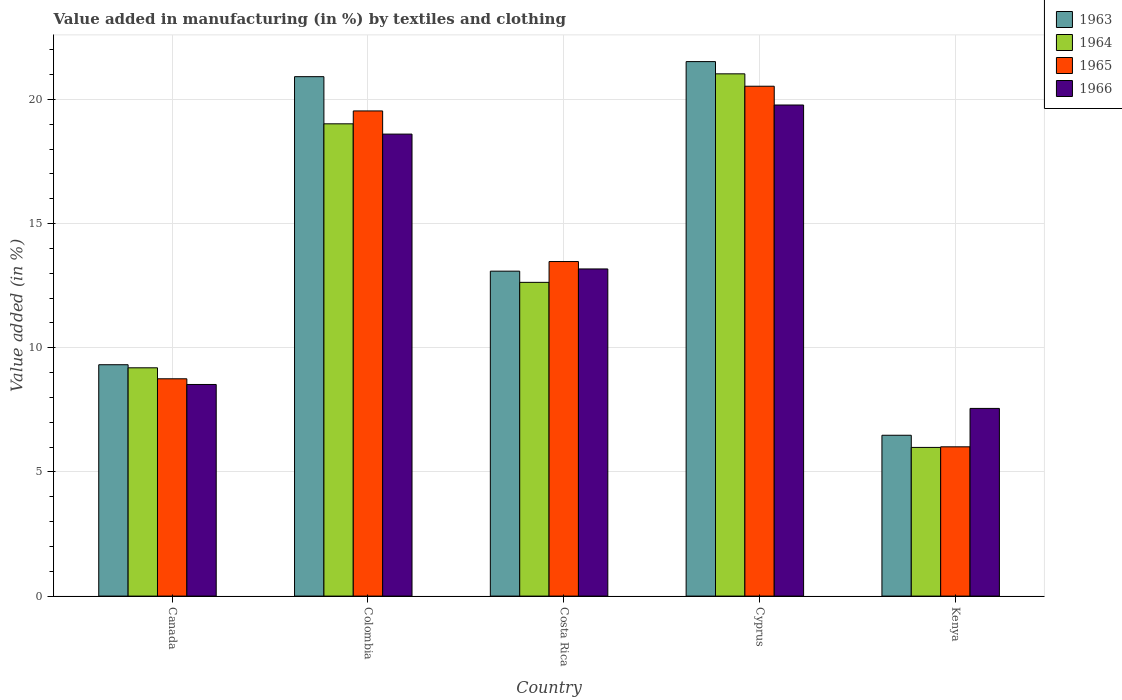How many different coloured bars are there?
Your answer should be very brief. 4. How many groups of bars are there?
Give a very brief answer. 5. How many bars are there on the 5th tick from the left?
Offer a very short reply. 4. What is the label of the 5th group of bars from the left?
Offer a terse response. Kenya. What is the percentage of value added in manufacturing by textiles and clothing in 1964 in Kenya?
Provide a succinct answer. 5.99. Across all countries, what is the maximum percentage of value added in manufacturing by textiles and clothing in 1964?
Your response must be concise. 21.03. Across all countries, what is the minimum percentage of value added in manufacturing by textiles and clothing in 1964?
Provide a succinct answer. 5.99. In which country was the percentage of value added in manufacturing by textiles and clothing in 1966 maximum?
Offer a very short reply. Cyprus. In which country was the percentage of value added in manufacturing by textiles and clothing in 1964 minimum?
Your answer should be compact. Kenya. What is the total percentage of value added in manufacturing by textiles and clothing in 1963 in the graph?
Make the answer very short. 71.32. What is the difference between the percentage of value added in manufacturing by textiles and clothing in 1963 in Canada and that in Colombia?
Provide a short and direct response. -11.6. What is the difference between the percentage of value added in manufacturing by textiles and clothing in 1966 in Kenya and the percentage of value added in manufacturing by textiles and clothing in 1965 in Colombia?
Offer a very short reply. -11.98. What is the average percentage of value added in manufacturing by textiles and clothing in 1965 per country?
Ensure brevity in your answer.  13.66. What is the difference between the percentage of value added in manufacturing by textiles and clothing of/in 1964 and percentage of value added in manufacturing by textiles and clothing of/in 1963 in Costa Rica?
Make the answer very short. -0.45. In how many countries, is the percentage of value added in manufacturing by textiles and clothing in 1964 greater than 9 %?
Give a very brief answer. 4. What is the ratio of the percentage of value added in manufacturing by textiles and clothing in 1966 in Canada to that in Cyprus?
Your answer should be very brief. 0.43. Is the difference between the percentage of value added in manufacturing by textiles and clothing in 1964 in Colombia and Kenya greater than the difference between the percentage of value added in manufacturing by textiles and clothing in 1963 in Colombia and Kenya?
Keep it short and to the point. No. What is the difference between the highest and the second highest percentage of value added in manufacturing by textiles and clothing in 1965?
Your response must be concise. -0.99. What is the difference between the highest and the lowest percentage of value added in manufacturing by textiles and clothing in 1966?
Make the answer very short. 12.22. In how many countries, is the percentage of value added in manufacturing by textiles and clothing in 1964 greater than the average percentage of value added in manufacturing by textiles and clothing in 1964 taken over all countries?
Ensure brevity in your answer.  2. Is it the case that in every country, the sum of the percentage of value added in manufacturing by textiles and clothing in 1963 and percentage of value added in manufacturing by textiles and clothing in 1966 is greater than the sum of percentage of value added in manufacturing by textiles and clothing in 1965 and percentage of value added in manufacturing by textiles and clothing in 1964?
Ensure brevity in your answer.  No. What does the 3rd bar from the left in Canada represents?
Offer a terse response. 1965. What does the 1st bar from the right in Colombia represents?
Make the answer very short. 1966. Is it the case that in every country, the sum of the percentage of value added in manufacturing by textiles and clothing in 1965 and percentage of value added in manufacturing by textiles and clothing in 1966 is greater than the percentage of value added in manufacturing by textiles and clothing in 1963?
Provide a short and direct response. Yes. How many countries are there in the graph?
Offer a very short reply. 5. What is the difference between two consecutive major ticks on the Y-axis?
Your response must be concise. 5. Are the values on the major ticks of Y-axis written in scientific E-notation?
Provide a short and direct response. No. How are the legend labels stacked?
Make the answer very short. Vertical. What is the title of the graph?
Give a very brief answer. Value added in manufacturing (in %) by textiles and clothing. What is the label or title of the Y-axis?
Give a very brief answer. Value added (in %). What is the Value added (in %) of 1963 in Canada?
Provide a succinct answer. 9.32. What is the Value added (in %) of 1964 in Canada?
Your answer should be very brief. 9.19. What is the Value added (in %) of 1965 in Canada?
Give a very brief answer. 8.75. What is the Value added (in %) of 1966 in Canada?
Ensure brevity in your answer.  8.52. What is the Value added (in %) of 1963 in Colombia?
Your response must be concise. 20.92. What is the Value added (in %) of 1964 in Colombia?
Offer a terse response. 19.02. What is the Value added (in %) of 1965 in Colombia?
Your answer should be very brief. 19.54. What is the Value added (in %) in 1966 in Colombia?
Provide a short and direct response. 18.6. What is the Value added (in %) in 1963 in Costa Rica?
Ensure brevity in your answer.  13.08. What is the Value added (in %) of 1964 in Costa Rica?
Your answer should be very brief. 12.63. What is the Value added (in %) in 1965 in Costa Rica?
Make the answer very short. 13.47. What is the Value added (in %) of 1966 in Costa Rica?
Keep it short and to the point. 13.17. What is the Value added (in %) of 1963 in Cyprus?
Offer a very short reply. 21.52. What is the Value added (in %) of 1964 in Cyprus?
Keep it short and to the point. 21.03. What is the Value added (in %) in 1965 in Cyprus?
Your answer should be very brief. 20.53. What is the Value added (in %) in 1966 in Cyprus?
Make the answer very short. 19.78. What is the Value added (in %) in 1963 in Kenya?
Keep it short and to the point. 6.48. What is the Value added (in %) of 1964 in Kenya?
Your answer should be compact. 5.99. What is the Value added (in %) of 1965 in Kenya?
Provide a short and direct response. 6.01. What is the Value added (in %) of 1966 in Kenya?
Your answer should be compact. 7.56. Across all countries, what is the maximum Value added (in %) of 1963?
Give a very brief answer. 21.52. Across all countries, what is the maximum Value added (in %) of 1964?
Your answer should be compact. 21.03. Across all countries, what is the maximum Value added (in %) in 1965?
Provide a succinct answer. 20.53. Across all countries, what is the maximum Value added (in %) of 1966?
Offer a terse response. 19.78. Across all countries, what is the minimum Value added (in %) of 1963?
Provide a short and direct response. 6.48. Across all countries, what is the minimum Value added (in %) in 1964?
Offer a terse response. 5.99. Across all countries, what is the minimum Value added (in %) in 1965?
Provide a succinct answer. 6.01. Across all countries, what is the minimum Value added (in %) in 1966?
Offer a terse response. 7.56. What is the total Value added (in %) in 1963 in the graph?
Keep it short and to the point. 71.32. What is the total Value added (in %) in 1964 in the graph?
Your answer should be very brief. 67.86. What is the total Value added (in %) in 1965 in the graph?
Offer a terse response. 68.3. What is the total Value added (in %) in 1966 in the graph?
Offer a very short reply. 67.63. What is the difference between the Value added (in %) of 1963 in Canada and that in Colombia?
Provide a short and direct response. -11.6. What is the difference between the Value added (in %) of 1964 in Canada and that in Colombia?
Provide a short and direct response. -9.82. What is the difference between the Value added (in %) of 1965 in Canada and that in Colombia?
Your answer should be compact. -10.79. What is the difference between the Value added (in %) in 1966 in Canada and that in Colombia?
Provide a succinct answer. -10.08. What is the difference between the Value added (in %) in 1963 in Canada and that in Costa Rica?
Ensure brevity in your answer.  -3.77. What is the difference between the Value added (in %) of 1964 in Canada and that in Costa Rica?
Make the answer very short. -3.44. What is the difference between the Value added (in %) in 1965 in Canada and that in Costa Rica?
Your answer should be very brief. -4.72. What is the difference between the Value added (in %) of 1966 in Canada and that in Costa Rica?
Keep it short and to the point. -4.65. What is the difference between the Value added (in %) of 1963 in Canada and that in Cyprus?
Make the answer very short. -12.21. What is the difference between the Value added (in %) in 1964 in Canada and that in Cyprus?
Keep it short and to the point. -11.84. What is the difference between the Value added (in %) in 1965 in Canada and that in Cyprus?
Offer a terse response. -11.78. What is the difference between the Value added (in %) of 1966 in Canada and that in Cyprus?
Give a very brief answer. -11.25. What is the difference between the Value added (in %) of 1963 in Canada and that in Kenya?
Make the answer very short. 2.84. What is the difference between the Value added (in %) of 1964 in Canada and that in Kenya?
Make the answer very short. 3.21. What is the difference between the Value added (in %) in 1965 in Canada and that in Kenya?
Your answer should be compact. 2.74. What is the difference between the Value added (in %) of 1966 in Canada and that in Kenya?
Your answer should be very brief. 0.96. What is the difference between the Value added (in %) of 1963 in Colombia and that in Costa Rica?
Provide a short and direct response. 7.83. What is the difference between the Value added (in %) of 1964 in Colombia and that in Costa Rica?
Your answer should be very brief. 6.38. What is the difference between the Value added (in %) of 1965 in Colombia and that in Costa Rica?
Your answer should be compact. 6.06. What is the difference between the Value added (in %) in 1966 in Colombia and that in Costa Rica?
Keep it short and to the point. 5.43. What is the difference between the Value added (in %) in 1963 in Colombia and that in Cyprus?
Provide a short and direct response. -0.61. What is the difference between the Value added (in %) in 1964 in Colombia and that in Cyprus?
Ensure brevity in your answer.  -2.01. What is the difference between the Value added (in %) in 1965 in Colombia and that in Cyprus?
Give a very brief answer. -0.99. What is the difference between the Value added (in %) of 1966 in Colombia and that in Cyprus?
Your answer should be very brief. -1.17. What is the difference between the Value added (in %) of 1963 in Colombia and that in Kenya?
Provide a short and direct response. 14.44. What is the difference between the Value added (in %) in 1964 in Colombia and that in Kenya?
Your answer should be very brief. 13.03. What is the difference between the Value added (in %) of 1965 in Colombia and that in Kenya?
Offer a terse response. 13.53. What is the difference between the Value added (in %) of 1966 in Colombia and that in Kenya?
Provide a succinct answer. 11.05. What is the difference between the Value added (in %) of 1963 in Costa Rica and that in Cyprus?
Make the answer very short. -8.44. What is the difference between the Value added (in %) of 1964 in Costa Rica and that in Cyprus?
Offer a very short reply. -8.4. What is the difference between the Value added (in %) in 1965 in Costa Rica and that in Cyprus?
Provide a succinct answer. -7.06. What is the difference between the Value added (in %) of 1966 in Costa Rica and that in Cyprus?
Your response must be concise. -6.6. What is the difference between the Value added (in %) in 1963 in Costa Rica and that in Kenya?
Provide a succinct answer. 6.61. What is the difference between the Value added (in %) of 1964 in Costa Rica and that in Kenya?
Provide a short and direct response. 6.65. What is the difference between the Value added (in %) of 1965 in Costa Rica and that in Kenya?
Ensure brevity in your answer.  7.46. What is the difference between the Value added (in %) of 1966 in Costa Rica and that in Kenya?
Offer a terse response. 5.62. What is the difference between the Value added (in %) of 1963 in Cyprus and that in Kenya?
Ensure brevity in your answer.  15.05. What is the difference between the Value added (in %) of 1964 in Cyprus and that in Kenya?
Give a very brief answer. 15.04. What is the difference between the Value added (in %) of 1965 in Cyprus and that in Kenya?
Provide a succinct answer. 14.52. What is the difference between the Value added (in %) of 1966 in Cyprus and that in Kenya?
Give a very brief answer. 12.22. What is the difference between the Value added (in %) in 1963 in Canada and the Value added (in %) in 1964 in Colombia?
Offer a terse response. -9.7. What is the difference between the Value added (in %) of 1963 in Canada and the Value added (in %) of 1965 in Colombia?
Provide a succinct answer. -10.22. What is the difference between the Value added (in %) in 1963 in Canada and the Value added (in %) in 1966 in Colombia?
Offer a very short reply. -9.29. What is the difference between the Value added (in %) in 1964 in Canada and the Value added (in %) in 1965 in Colombia?
Offer a terse response. -10.34. What is the difference between the Value added (in %) in 1964 in Canada and the Value added (in %) in 1966 in Colombia?
Offer a terse response. -9.41. What is the difference between the Value added (in %) in 1965 in Canada and the Value added (in %) in 1966 in Colombia?
Offer a very short reply. -9.85. What is the difference between the Value added (in %) of 1963 in Canada and the Value added (in %) of 1964 in Costa Rica?
Your answer should be compact. -3.32. What is the difference between the Value added (in %) in 1963 in Canada and the Value added (in %) in 1965 in Costa Rica?
Provide a succinct answer. -4.16. What is the difference between the Value added (in %) of 1963 in Canada and the Value added (in %) of 1966 in Costa Rica?
Offer a very short reply. -3.86. What is the difference between the Value added (in %) of 1964 in Canada and the Value added (in %) of 1965 in Costa Rica?
Your answer should be compact. -4.28. What is the difference between the Value added (in %) in 1964 in Canada and the Value added (in %) in 1966 in Costa Rica?
Give a very brief answer. -3.98. What is the difference between the Value added (in %) of 1965 in Canada and the Value added (in %) of 1966 in Costa Rica?
Provide a short and direct response. -4.42. What is the difference between the Value added (in %) in 1963 in Canada and the Value added (in %) in 1964 in Cyprus?
Offer a terse response. -11.71. What is the difference between the Value added (in %) in 1963 in Canada and the Value added (in %) in 1965 in Cyprus?
Give a very brief answer. -11.21. What is the difference between the Value added (in %) of 1963 in Canada and the Value added (in %) of 1966 in Cyprus?
Keep it short and to the point. -10.46. What is the difference between the Value added (in %) in 1964 in Canada and the Value added (in %) in 1965 in Cyprus?
Your answer should be very brief. -11.34. What is the difference between the Value added (in %) of 1964 in Canada and the Value added (in %) of 1966 in Cyprus?
Provide a short and direct response. -10.58. What is the difference between the Value added (in %) of 1965 in Canada and the Value added (in %) of 1966 in Cyprus?
Your answer should be compact. -11.02. What is the difference between the Value added (in %) of 1963 in Canada and the Value added (in %) of 1964 in Kenya?
Provide a succinct answer. 3.33. What is the difference between the Value added (in %) of 1963 in Canada and the Value added (in %) of 1965 in Kenya?
Offer a very short reply. 3.31. What is the difference between the Value added (in %) of 1963 in Canada and the Value added (in %) of 1966 in Kenya?
Ensure brevity in your answer.  1.76. What is the difference between the Value added (in %) in 1964 in Canada and the Value added (in %) in 1965 in Kenya?
Provide a succinct answer. 3.18. What is the difference between the Value added (in %) in 1964 in Canada and the Value added (in %) in 1966 in Kenya?
Ensure brevity in your answer.  1.64. What is the difference between the Value added (in %) of 1965 in Canada and the Value added (in %) of 1966 in Kenya?
Your response must be concise. 1.19. What is the difference between the Value added (in %) of 1963 in Colombia and the Value added (in %) of 1964 in Costa Rica?
Offer a very short reply. 8.28. What is the difference between the Value added (in %) of 1963 in Colombia and the Value added (in %) of 1965 in Costa Rica?
Give a very brief answer. 7.44. What is the difference between the Value added (in %) in 1963 in Colombia and the Value added (in %) in 1966 in Costa Rica?
Keep it short and to the point. 7.74. What is the difference between the Value added (in %) of 1964 in Colombia and the Value added (in %) of 1965 in Costa Rica?
Ensure brevity in your answer.  5.55. What is the difference between the Value added (in %) of 1964 in Colombia and the Value added (in %) of 1966 in Costa Rica?
Keep it short and to the point. 5.84. What is the difference between the Value added (in %) in 1965 in Colombia and the Value added (in %) in 1966 in Costa Rica?
Provide a succinct answer. 6.36. What is the difference between the Value added (in %) in 1963 in Colombia and the Value added (in %) in 1964 in Cyprus?
Keep it short and to the point. -0.11. What is the difference between the Value added (in %) in 1963 in Colombia and the Value added (in %) in 1965 in Cyprus?
Make the answer very short. 0.39. What is the difference between the Value added (in %) in 1963 in Colombia and the Value added (in %) in 1966 in Cyprus?
Ensure brevity in your answer.  1.14. What is the difference between the Value added (in %) in 1964 in Colombia and the Value added (in %) in 1965 in Cyprus?
Keep it short and to the point. -1.51. What is the difference between the Value added (in %) in 1964 in Colombia and the Value added (in %) in 1966 in Cyprus?
Make the answer very short. -0.76. What is the difference between the Value added (in %) in 1965 in Colombia and the Value added (in %) in 1966 in Cyprus?
Keep it short and to the point. -0.24. What is the difference between the Value added (in %) in 1963 in Colombia and the Value added (in %) in 1964 in Kenya?
Provide a succinct answer. 14.93. What is the difference between the Value added (in %) of 1963 in Colombia and the Value added (in %) of 1965 in Kenya?
Offer a very short reply. 14.91. What is the difference between the Value added (in %) of 1963 in Colombia and the Value added (in %) of 1966 in Kenya?
Your answer should be compact. 13.36. What is the difference between the Value added (in %) in 1964 in Colombia and the Value added (in %) in 1965 in Kenya?
Your answer should be very brief. 13.01. What is the difference between the Value added (in %) in 1964 in Colombia and the Value added (in %) in 1966 in Kenya?
Make the answer very short. 11.46. What is the difference between the Value added (in %) in 1965 in Colombia and the Value added (in %) in 1966 in Kenya?
Keep it short and to the point. 11.98. What is the difference between the Value added (in %) in 1963 in Costa Rica and the Value added (in %) in 1964 in Cyprus?
Offer a very short reply. -7.95. What is the difference between the Value added (in %) of 1963 in Costa Rica and the Value added (in %) of 1965 in Cyprus?
Give a very brief answer. -7.45. What is the difference between the Value added (in %) in 1963 in Costa Rica and the Value added (in %) in 1966 in Cyprus?
Provide a short and direct response. -6.69. What is the difference between the Value added (in %) of 1964 in Costa Rica and the Value added (in %) of 1965 in Cyprus?
Your answer should be very brief. -7.9. What is the difference between the Value added (in %) of 1964 in Costa Rica and the Value added (in %) of 1966 in Cyprus?
Your answer should be compact. -7.14. What is the difference between the Value added (in %) of 1965 in Costa Rica and the Value added (in %) of 1966 in Cyprus?
Keep it short and to the point. -6.3. What is the difference between the Value added (in %) in 1963 in Costa Rica and the Value added (in %) in 1964 in Kenya?
Give a very brief answer. 7.1. What is the difference between the Value added (in %) in 1963 in Costa Rica and the Value added (in %) in 1965 in Kenya?
Provide a short and direct response. 7.07. What is the difference between the Value added (in %) of 1963 in Costa Rica and the Value added (in %) of 1966 in Kenya?
Provide a short and direct response. 5.53. What is the difference between the Value added (in %) in 1964 in Costa Rica and the Value added (in %) in 1965 in Kenya?
Provide a succinct answer. 6.62. What is the difference between the Value added (in %) of 1964 in Costa Rica and the Value added (in %) of 1966 in Kenya?
Offer a terse response. 5.08. What is the difference between the Value added (in %) of 1965 in Costa Rica and the Value added (in %) of 1966 in Kenya?
Offer a terse response. 5.91. What is the difference between the Value added (in %) of 1963 in Cyprus and the Value added (in %) of 1964 in Kenya?
Keep it short and to the point. 15.54. What is the difference between the Value added (in %) in 1963 in Cyprus and the Value added (in %) in 1965 in Kenya?
Give a very brief answer. 15.51. What is the difference between the Value added (in %) of 1963 in Cyprus and the Value added (in %) of 1966 in Kenya?
Provide a short and direct response. 13.97. What is the difference between the Value added (in %) in 1964 in Cyprus and the Value added (in %) in 1965 in Kenya?
Provide a succinct answer. 15.02. What is the difference between the Value added (in %) of 1964 in Cyprus and the Value added (in %) of 1966 in Kenya?
Provide a succinct answer. 13.47. What is the difference between the Value added (in %) in 1965 in Cyprus and the Value added (in %) in 1966 in Kenya?
Offer a terse response. 12.97. What is the average Value added (in %) in 1963 per country?
Keep it short and to the point. 14.26. What is the average Value added (in %) in 1964 per country?
Your response must be concise. 13.57. What is the average Value added (in %) in 1965 per country?
Keep it short and to the point. 13.66. What is the average Value added (in %) of 1966 per country?
Your answer should be compact. 13.53. What is the difference between the Value added (in %) in 1963 and Value added (in %) in 1964 in Canada?
Ensure brevity in your answer.  0.12. What is the difference between the Value added (in %) of 1963 and Value added (in %) of 1965 in Canada?
Provide a succinct answer. 0.57. What is the difference between the Value added (in %) of 1963 and Value added (in %) of 1966 in Canada?
Offer a very short reply. 0.8. What is the difference between the Value added (in %) in 1964 and Value added (in %) in 1965 in Canada?
Give a very brief answer. 0.44. What is the difference between the Value added (in %) in 1964 and Value added (in %) in 1966 in Canada?
Provide a succinct answer. 0.67. What is the difference between the Value added (in %) in 1965 and Value added (in %) in 1966 in Canada?
Ensure brevity in your answer.  0.23. What is the difference between the Value added (in %) of 1963 and Value added (in %) of 1964 in Colombia?
Your response must be concise. 1.9. What is the difference between the Value added (in %) of 1963 and Value added (in %) of 1965 in Colombia?
Give a very brief answer. 1.38. What is the difference between the Value added (in %) in 1963 and Value added (in %) in 1966 in Colombia?
Provide a succinct answer. 2.31. What is the difference between the Value added (in %) in 1964 and Value added (in %) in 1965 in Colombia?
Provide a succinct answer. -0.52. What is the difference between the Value added (in %) in 1964 and Value added (in %) in 1966 in Colombia?
Ensure brevity in your answer.  0.41. What is the difference between the Value added (in %) in 1965 and Value added (in %) in 1966 in Colombia?
Provide a succinct answer. 0.93. What is the difference between the Value added (in %) in 1963 and Value added (in %) in 1964 in Costa Rica?
Make the answer very short. 0.45. What is the difference between the Value added (in %) in 1963 and Value added (in %) in 1965 in Costa Rica?
Your answer should be compact. -0.39. What is the difference between the Value added (in %) of 1963 and Value added (in %) of 1966 in Costa Rica?
Make the answer very short. -0.09. What is the difference between the Value added (in %) of 1964 and Value added (in %) of 1965 in Costa Rica?
Keep it short and to the point. -0.84. What is the difference between the Value added (in %) in 1964 and Value added (in %) in 1966 in Costa Rica?
Give a very brief answer. -0.54. What is the difference between the Value added (in %) of 1965 and Value added (in %) of 1966 in Costa Rica?
Keep it short and to the point. 0.3. What is the difference between the Value added (in %) of 1963 and Value added (in %) of 1964 in Cyprus?
Your answer should be compact. 0.49. What is the difference between the Value added (in %) in 1963 and Value added (in %) in 1966 in Cyprus?
Give a very brief answer. 1.75. What is the difference between the Value added (in %) of 1964 and Value added (in %) of 1965 in Cyprus?
Give a very brief answer. 0.5. What is the difference between the Value added (in %) in 1964 and Value added (in %) in 1966 in Cyprus?
Your response must be concise. 1.25. What is the difference between the Value added (in %) in 1965 and Value added (in %) in 1966 in Cyprus?
Provide a short and direct response. 0.76. What is the difference between the Value added (in %) of 1963 and Value added (in %) of 1964 in Kenya?
Ensure brevity in your answer.  0.49. What is the difference between the Value added (in %) in 1963 and Value added (in %) in 1965 in Kenya?
Your answer should be compact. 0.47. What is the difference between the Value added (in %) of 1963 and Value added (in %) of 1966 in Kenya?
Provide a succinct answer. -1.08. What is the difference between the Value added (in %) in 1964 and Value added (in %) in 1965 in Kenya?
Your answer should be compact. -0.02. What is the difference between the Value added (in %) of 1964 and Value added (in %) of 1966 in Kenya?
Your answer should be very brief. -1.57. What is the difference between the Value added (in %) of 1965 and Value added (in %) of 1966 in Kenya?
Give a very brief answer. -1.55. What is the ratio of the Value added (in %) of 1963 in Canada to that in Colombia?
Your response must be concise. 0.45. What is the ratio of the Value added (in %) of 1964 in Canada to that in Colombia?
Offer a terse response. 0.48. What is the ratio of the Value added (in %) of 1965 in Canada to that in Colombia?
Your response must be concise. 0.45. What is the ratio of the Value added (in %) in 1966 in Canada to that in Colombia?
Keep it short and to the point. 0.46. What is the ratio of the Value added (in %) in 1963 in Canada to that in Costa Rica?
Provide a short and direct response. 0.71. What is the ratio of the Value added (in %) of 1964 in Canada to that in Costa Rica?
Provide a short and direct response. 0.73. What is the ratio of the Value added (in %) in 1965 in Canada to that in Costa Rica?
Ensure brevity in your answer.  0.65. What is the ratio of the Value added (in %) in 1966 in Canada to that in Costa Rica?
Ensure brevity in your answer.  0.65. What is the ratio of the Value added (in %) in 1963 in Canada to that in Cyprus?
Keep it short and to the point. 0.43. What is the ratio of the Value added (in %) of 1964 in Canada to that in Cyprus?
Ensure brevity in your answer.  0.44. What is the ratio of the Value added (in %) of 1965 in Canada to that in Cyprus?
Your answer should be compact. 0.43. What is the ratio of the Value added (in %) in 1966 in Canada to that in Cyprus?
Offer a terse response. 0.43. What is the ratio of the Value added (in %) in 1963 in Canada to that in Kenya?
Offer a very short reply. 1.44. What is the ratio of the Value added (in %) of 1964 in Canada to that in Kenya?
Your response must be concise. 1.54. What is the ratio of the Value added (in %) of 1965 in Canada to that in Kenya?
Make the answer very short. 1.46. What is the ratio of the Value added (in %) of 1966 in Canada to that in Kenya?
Ensure brevity in your answer.  1.13. What is the ratio of the Value added (in %) in 1963 in Colombia to that in Costa Rica?
Give a very brief answer. 1.6. What is the ratio of the Value added (in %) in 1964 in Colombia to that in Costa Rica?
Provide a succinct answer. 1.51. What is the ratio of the Value added (in %) in 1965 in Colombia to that in Costa Rica?
Provide a short and direct response. 1.45. What is the ratio of the Value added (in %) in 1966 in Colombia to that in Costa Rica?
Keep it short and to the point. 1.41. What is the ratio of the Value added (in %) of 1963 in Colombia to that in Cyprus?
Give a very brief answer. 0.97. What is the ratio of the Value added (in %) in 1964 in Colombia to that in Cyprus?
Provide a succinct answer. 0.9. What is the ratio of the Value added (in %) in 1965 in Colombia to that in Cyprus?
Give a very brief answer. 0.95. What is the ratio of the Value added (in %) in 1966 in Colombia to that in Cyprus?
Keep it short and to the point. 0.94. What is the ratio of the Value added (in %) of 1963 in Colombia to that in Kenya?
Make the answer very short. 3.23. What is the ratio of the Value added (in %) of 1964 in Colombia to that in Kenya?
Your answer should be very brief. 3.18. What is the ratio of the Value added (in %) of 1965 in Colombia to that in Kenya?
Offer a very short reply. 3.25. What is the ratio of the Value added (in %) of 1966 in Colombia to that in Kenya?
Your answer should be compact. 2.46. What is the ratio of the Value added (in %) in 1963 in Costa Rica to that in Cyprus?
Keep it short and to the point. 0.61. What is the ratio of the Value added (in %) in 1964 in Costa Rica to that in Cyprus?
Give a very brief answer. 0.6. What is the ratio of the Value added (in %) in 1965 in Costa Rica to that in Cyprus?
Make the answer very short. 0.66. What is the ratio of the Value added (in %) in 1966 in Costa Rica to that in Cyprus?
Make the answer very short. 0.67. What is the ratio of the Value added (in %) in 1963 in Costa Rica to that in Kenya?
Give a very brief answer. 2.02. What is the ratio of the Value added (in %) in 1964 in Costa Rica to that in Kenya?
Ensure brevity in your answer.  2.11. What is the ratio of the Value added (in %) of 1965 in Costa Rica to that in Kenya?
Your response must be concise. 2.24. What is the ratio of the Value added (in %) in 1966 in Costa Rica to that in Kenya?
Ensure brevity in your answer.  1.74. What is the ratio of the Value added (in %) of 1963 in Cyprus to that in Kenya?
Provide a short and direct response. 3.32. What is the ratio of the Value added (in %) of 1964 in Cyprus to that in Kenya?
Your response must be concise. 3.51. What is the ratio of the Value added (in %) in 1965 in Cyprus to that in Kenya?
Offer a very short reply. 3.42. What is the ratio of the Value added (in %) of 1966 in Cyprus to that in Kenya?
Keep it short and to the point. 2.62. What is the difference between the highest and the second highest Value added (in %) of 1963?
Ensure brevity in your answer.  0.61. What is the difference between the highest and the second highest Value added (in %) in 1964?
Your answer should be very brief. 2.01. What is the difference between the highest and the second highest Value added (in %) of 1965?
Ensure brevity in your answer.  0.99. What is the difference between the highest and the second highest Value added (in %) of 1966?
Provide a short and direct response. 1.17. What is the difference between the highest and the lowest Value added (in %) in 1963?
Offer a very short reply. 15.05. What is the difference between the highest and the lowest Value added (in %) of 1964?
Ensure brevity in your answer.  15.04. What is the difference between the highest and the lowest Value added (in %) of 1965?
Offer a very short reply. 14.52. What is the difference between the highest and the lowest Value added (in %) in 1966?
Provide a short and direct response. 12.22. 